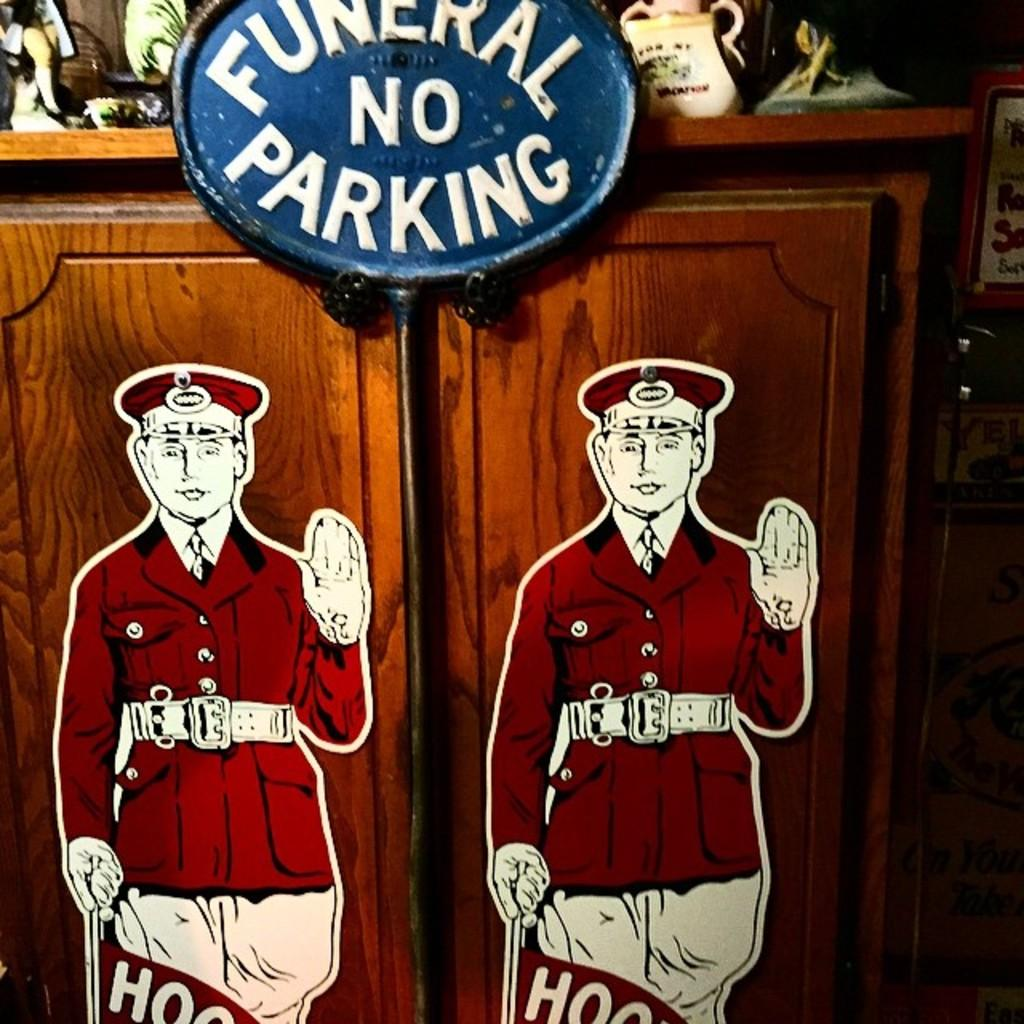<image>
Relay a brief, clear account of the picture shown. A sign hanging on a wooden cabinet says "funeral no parking". 